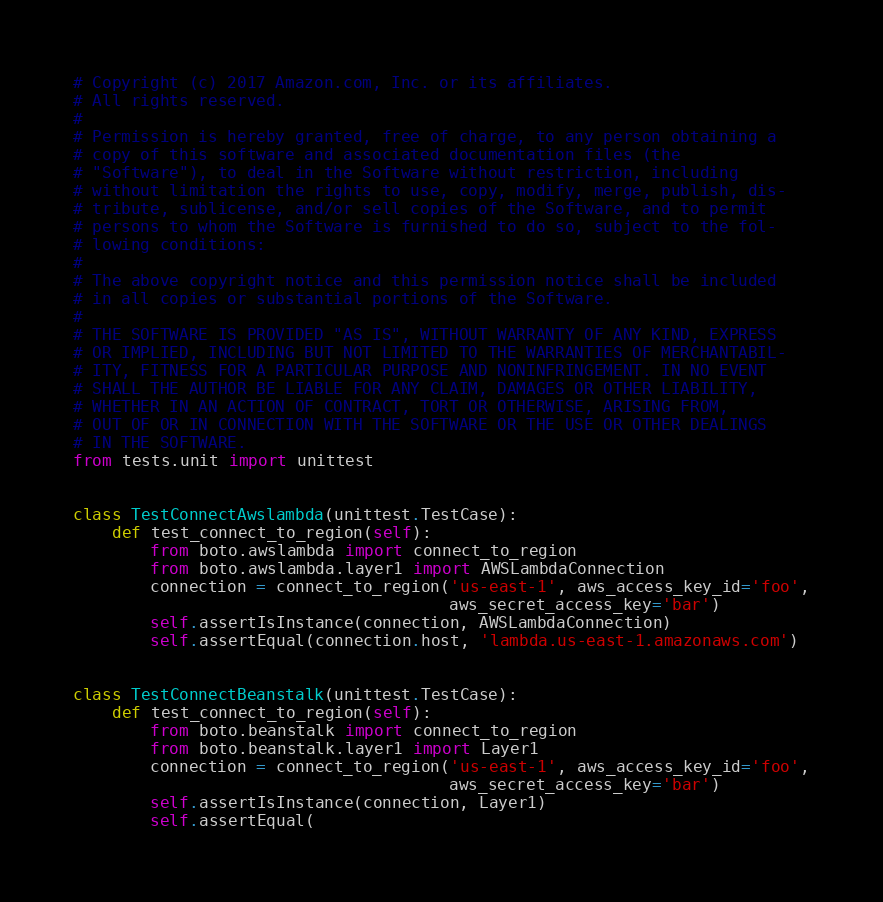Convert code to text. <code><loc_0><loc_0><loc_500><loc_500><_Python_># Copyright (c) 2017 Amazon.com, Inc. or its affiliates.
# All rights reserved.
#
# Permission is hereby granted, free of charge, to any person obtaining a
# copy of this software and associated documentation files (the
# "Software"), to deal in the Software without restriction, including
# without limitation the rights to use, copy, modify, merge, publish, dis-
# tribute, sublicense, and/or sell copies of the Software, and to permit
# persons to whom the Software is furnished to do so, subject to the fol-
# lowing conditions:
#
# The above copyright notice and this permission notice shall be included
# in all copies or substantial portions of the Software.
#
# THE SOFTWARE IS PROVIDED "AS IS", WITHOUT WARRANTY OF ANY KIND, EXPRESS
# OR IMPLIED, INCLUDING BUT NOT LIMITED TO THE WARRANTIES OF MERCHANTABIL-
# ITY, FITNESS FOR A PARTICULAR PURPOSE AND NONINFRINGEMENT. IN NO EVENT
# SHALL THE AUTHOR BE LIABLE FOR ANY CLAIM, DAMAGES OR OTHER LIABILITY,
# WHETHER IN AN ACTION OF CONTRACT, TORT OR OTHERWISE, ARISING FROM,
# OUT OF OR IN CONNECTION WITH THE SOFTWARE OR THE USE OR OTHER DEALINGS
# IN THE SOFTWARE.
from tests.unit import unittest


class TestConnectAwslambda(unittest.TestCase):
    def test_connect_to_region(self):
        from boto.awslambda import connect_to_region
        from boto.awslambda.layer1 import AWSLambdaConnection
        connection = connect_to_region('us-east-1', aws_access_key_id='foo',
                                       aws_secret_access_key='bar')
        self.assertIsInstance(connection, AWSLambdaConnection)
        self.assertEqual(connection.host, 'lambda.us-east-1.amazonaws.com')


class TestConnectBeanstalk(unittest.TestCase):
    def test_connect_to_region(self):
        from boto.beanstalk import connect_to_region
        from boto.beanstalk.layer1 import Layer1
        connection = connect_to_region('us-east-1', aws_access_key_id='foo',
                                       aws_secret_access_key='bar')
        self.assertIsInstance(connection, Layer1)
        self.assertEqual(</code> 